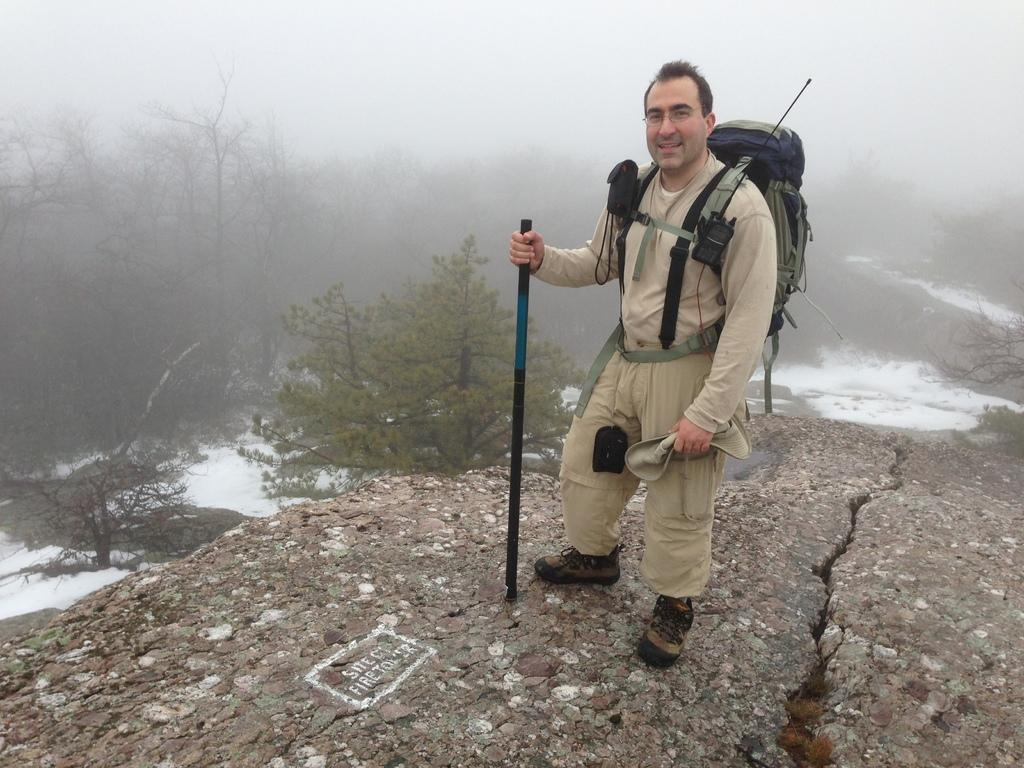What is the main subject in the foreground of the image? There is a man in the foreground of the image. What is the man wearing? The man is wearing a bag. What is the man holding in the image? The man is holding a trekking stick. What type of terrain is the man standing on? The man is standing on the land. What can be seen in the background of the image? There are trees and a foggy sky in the background of the image. What type of sign can be seen in the image? There is no sign present in the image. What day of the week is it in the image? The day of the week cannot be determined from the image. 